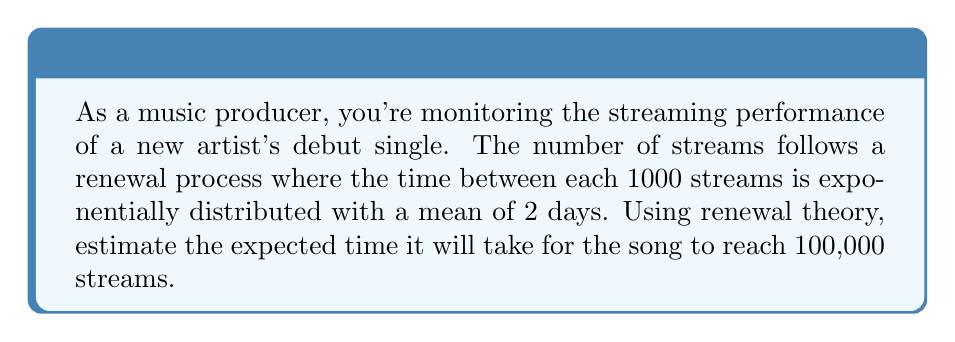Help me with this question. To solve this problem, we'll use the concept of renewal processes and the properties of exponential distribution.

Step 1: Identify the renewal process
- Each renewal occurs every 1000 streams
- The time between renewals is exponentially distributed with mean 2 days

Step 2: Calculate the number of renewals needed
- Target: 100,000 streams
- Renewals occur every 1000 streams
- Number of renewals = $\frac{100,000}{1000} = 100$

Step 3: Use the renewal function
For a renewal process with exponentially distributed inter-arrival times, the expected number of renewals $E[N(t)]$ by time $t$ is given by:

$$E[N(t)] = \frac{t}{\mu}$$

where $\mu$ is the mean inter-arrival time.

Step 4: Rearrange the equation to solve for $t$
We want to find $t$ when $E[N(t)] = 100$:

$$100 = \frac{t}{2}$$
$$t = 100 \cdot 2 = 200$$

Therefore, the expected time to reach 100,000 streams is 200 days.
Answer: 200 days 